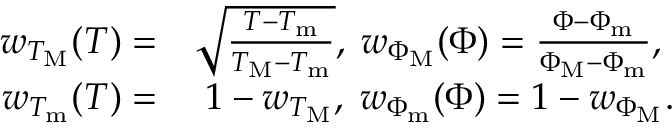Convert formula to latex. <formula><loc_0><loc_0><loc_500><loc_500>\begin{array} { r l } { w _ { T _ { M } } ( T ) = } & { \sqrt { \frac { T - T _ { m } } { T _ { M } - T _ { m } } } , \, w _ { \Phi _ { M } } ( \Phi ) = \frac { \Phi - \Phi _ { m } } { \Phi _ { M } - \Phi _ { m } } , } \\ { w _ { T _ { m } } ( T ) = } & { \, 1 - w _ { T _ { M } } , \, w _ { \Phi _ { m } } ( \Phi ) = 1 - w _ { \Phi _ { M } } . } \end{array}</formula> 